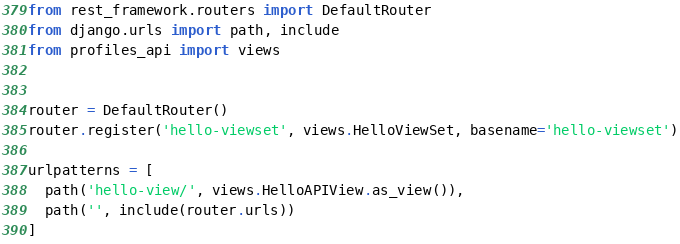Convert code to text. <code><loc_0><loc_0><loc_500><loc_500><_Python_>from rest_framework.routers import DefaultRouter
from django.urls import path, include
from profiles_api import views


router = DefaultRouter()
router.register('hello-viewset', views.HelloViewSet, basename='hello-viewset')

urlpatterns = [
  path('hello-view/', views.HelloAPIView.as_view()),
  path('', include(router.urls))
]
</code> 